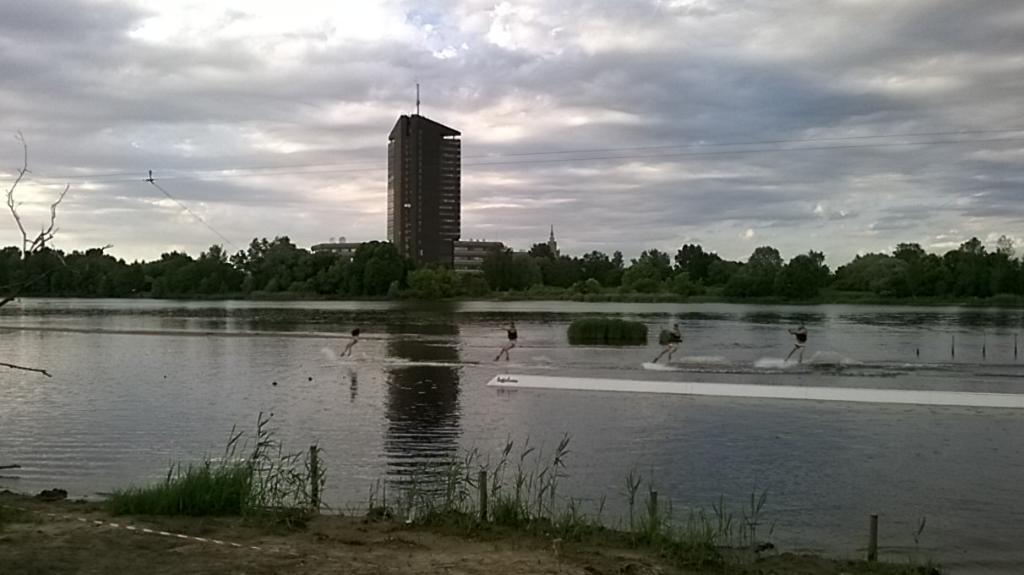What can be seen in the background of the image? There is a building and trees in the background of the image. What natural element is visible in the image? Water is visible in the image. What type of terrain is at the bottom of the image? There is sand at the bottom of the image. What type of game is being played on the sand in the image? There is no game being played in the image; it only shows water, sand, and a background with a building and trees. 